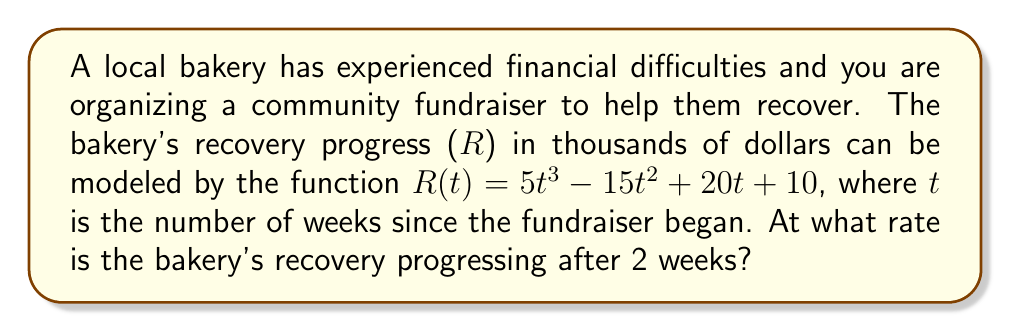Can you solve this math problem? To determine the rate of change in the bakery's recovery after 2 weeks, we need to find the derivative of the recovery function R(t) and evaluate it at t = 2.

Step 1: Find the derivative of R(t)
$$R(t) = 5t^3 - 15t^2 + 20t + 10$$
$$R'(t) = 15t^2 - 30t + 20$$

Step 2: Evaluate R'(t) at t = 2
$$R'(2) = 15(2)^2 - 30(2) + 20$$
$$R'(2) = 15(4) - 60 + 20$$
$$R'(2) = 60 - 60 + 20$$
$$R'(2) = 20$$

Therefore, after 2 weeks, the bakery's recovery is progressing at a rate of 20 thousand dollars per week.
Answer: $20$ thousand dollars per week 